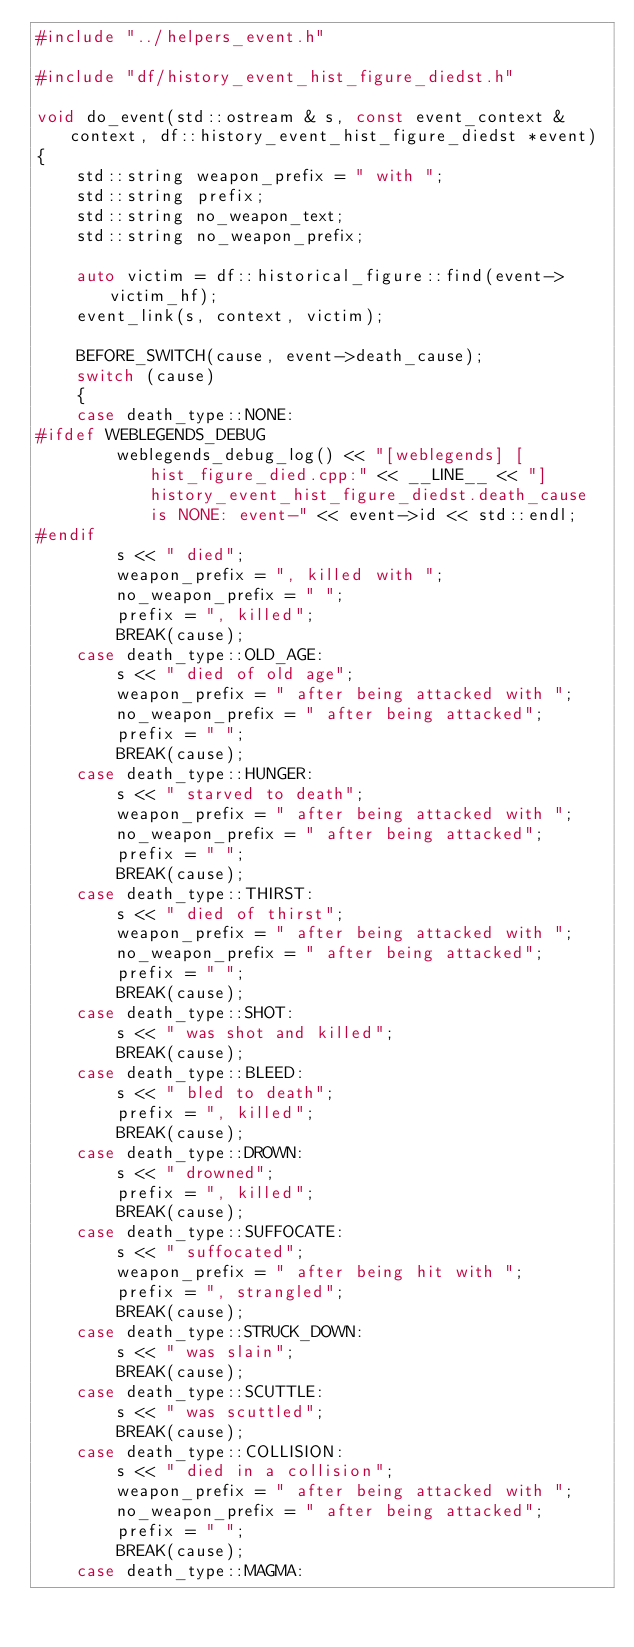Convert code to text. <code><loc_0><loc_0><loc_500><loc_500><_C++_>#include "../helpers_event.h"

#include "df/history_event_hist_figure_diedst.h"

void do_event(std::ostream & s, const event_context & context, df::history_event_hist_figure_diedst *event)
{
    std::string weapon_prefix = " with ";
    std::string prefix;
    std::string no_weapon_text;
    std::string no_weapon_prefix;

    auto victim = df::historical_figure::find(event->victim_hf);
    event_link(s, context, victim);

    BEFORE_SWITCH(cause, event->death_cause);
    switch (cause)
    {
    case death_type::NONE:
#ifdef WEBLEGENDS_DEBUG
        weblegends_debug_log() << "[weblegends] [hist_figure_died.cpp:" << __LINE__ << "] history_event_hist_figure_diedst.death_cause is NONE: event-" << event->id << std::endl;
#endif
        s << " died";
        weapon_prefix = ", killed with ";
        no_weapon_prefix = " ";
        prefix = ", killed";
        BREAK(cause);
    case death_type::OLD_AGE:
        s << " died of old age";
        weapon_prefix = " after being attacked with ";
        no_weapon_prefix = " after being attacked";
        prefix = " ";
        BREAK(cause);
    case death_type::HUNGER:
        s << " starved to death";
        weapon_prefix = " after being attacked with ";
        no_weapon_prefix = " after being attacked";
        prefix = " ";
        BREAK(cause);
    case death_type::THIRST:
        s << " died of thirst";
        weapon_prefix = " after being attacked with ";
        no_weapon_prefix = " after being attacked";
        prefix = " ";
        BREAK(cause);
    case death_type::SHOT:
        s << " was shot and killed";
        BREAK(cause);
    case death_type::BLEED:
        s << " bled to death";
        prefix = ", killed";
        BREAK(cause);
    case death_type::DROWN:
        s << " drowned";
        prefix = ", killed";
        BREAK(cause);
    case death_type::SUFFOCATE:
        s << " suffocated";
        weapon_prefix = " after being hit with ";
        prefix = ", strangled";
        BREAK(cause);
    case death_type::STRUCK_DOWN:
        s << " was slain";
        BREAK(cause);
    case death_type::SCUTTLE:
        s << " was scuttled";
        BREAK(cause);
    case death_type::COLLISION:
        s << " died in a collision";
        weapon_prefix = " after being attacked with ";
        no_weapon_prefix = " after being attacked";
        prefix = " ";
        BREAK(cause);
    case death_type::MAGMA:</code> 